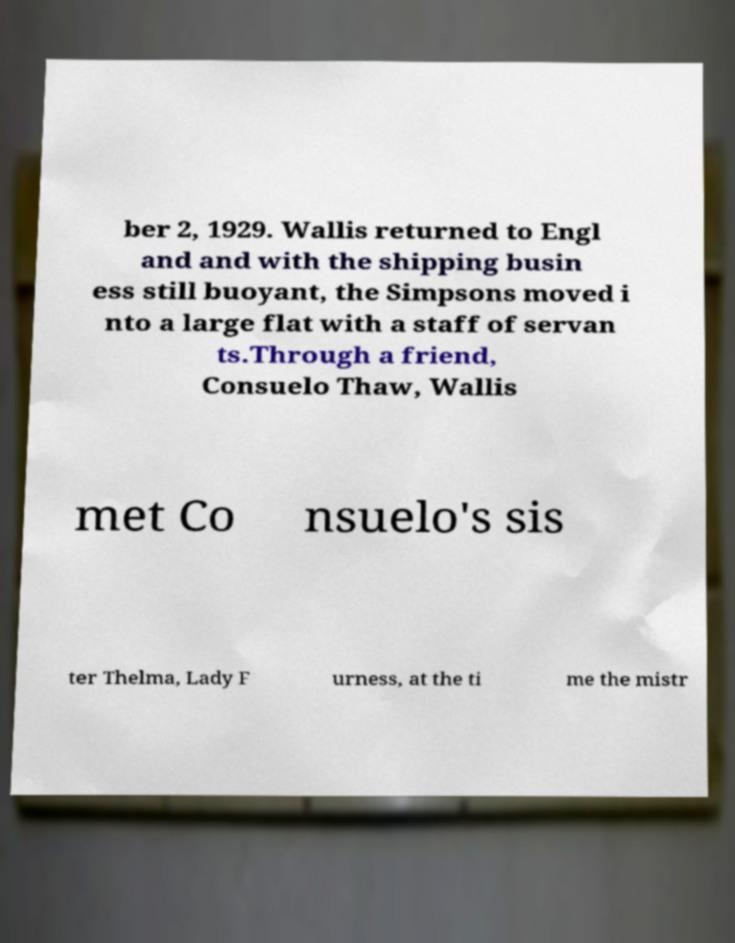Can you accurately transcribe the text from the provided image for me? ber 2, 1929. Wallis returned to Engl and and with the shipping busin ess still buoyant, the Simpsons moved i nto a large flat with a staff of servan ts.Through a friend, Consuelo Thaw, Wallis met Co nsuelo's sis ter Thelma, Lady F urness, at the ti me the mistr 